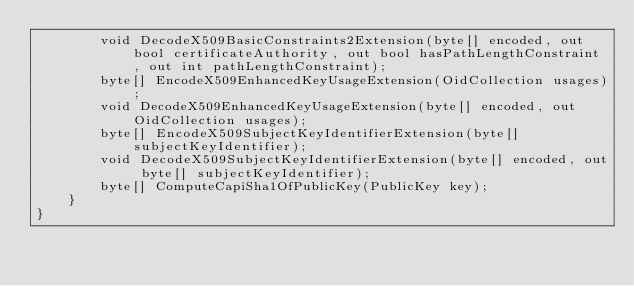<code> <loc_0><loc_0><loc_500><loc_500><_C#_>        void DecodeX509BasicConstraints2Extension(byte[] encoded, out bool certificateAuthority, out bool hasPathLengthConstraint, out int pathLengthConstraint);
        byte[] EncodeX509EnhancedKeyUsageExtension(OidCollection usages);
        void DecodeX509EnhancedKeyUsageExtension(byte[] encoded, out OidCollection usages);
        byte[] EncodeX509SubjectKeyIdentifierExtension(byte[] subjectKeyIdentifier);
        void DecodeX509SubjectKeyIdentifierExtension(byte[] encoded, out byte[] subjectKeyIdentifier);
        byte[] ComputeCapiSha1OfPublicKey(PublicKey key);
    }
}
</code> 